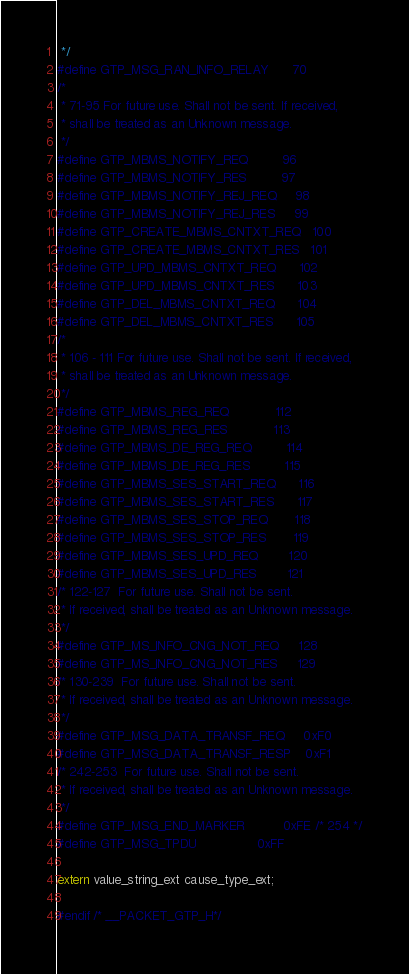Convert code to text. <code><loc_0><loc_0><loc_500><loc_500><_C_> */
#define GTP_MSG_RAN_INFO_RELAY      70
/*
 * 71-95 For future use. Shall not be sent. If received,
 * shall be treated as an Unknown message.
 */
#define GTP_MBMS_NOTIFY_REQ         96
#define GTP_MBMS_NOTIFY_RES         97
#define GTP_MBMS_NOTIFY_REJ_REQ     98
#define GTP_MBMS_NOTIFY_REJ_RES     99
#define GTP_CREATE_MBMS_CNTXT_REQ   100
#define GTP_CREATE_MBMS_CNTXT_RES   101
#define GTP_UPD_MBMS_CNTXT_REQ      102
#define GTP_UPD_MBMS_CNTXT_RES      103
#define GTP_DEL_MBMS_CNTXT_REQ      104
#define GTP_DEL_MBMS_CNTXT_RES      105
/*
 * 106 - 111 For future use. Shall not be sent. If received,
 * shall be treated as an Unknown message.
 */
#define GTP_MBMS_REG_REQ            112
#define GTP_MBMS_REG_RES            113
#define GTP_MBMS_DE_REG_REQ         114
#define GTP_MBMS_DE_REG_RES         115
#define GTP_MBMS_SES_START_REQ      116
#define GTP_MBMS_SES_START_RES      117
#define GTP_MBMS_SES_STOP_REQ       118
#define GTP_MBMS_SES_STOP_RES       119
#define GTP_MBMS_SES_UPD_REQ        120
#define GTP_MBMS_SES_UPD_RES        121
/* 122-127  For future use. Shall not be sent.
 * If received, shall be treated as an Unknown message.
 */
#define GTP_MS_INFO_CNG_NOT_REQ     128
#define GTP_MS_INFO_CNG_NOT_RES     129
/* 130-239  For future use. Shall not be sent.
 * If received, shall be treated as an Unknown message.
 */
#define GTP_MSG_DATA_TRANSF_REQ     0xF0
#define GTP_MSG_DATA_TRANSF_RESP    0xF1
/* 242-253  For future use. Shall not be sent.
 * If received, shall be treated as an Unknown message.
 */
#define GTP_MSG_END_MARKER          0xFE /* 254 */
#define GTP_MSG_TPDU                0xFF

extern value_string_ext cause_type_ext;

#endif /* __PACKET_GTP_H*/
</code> 